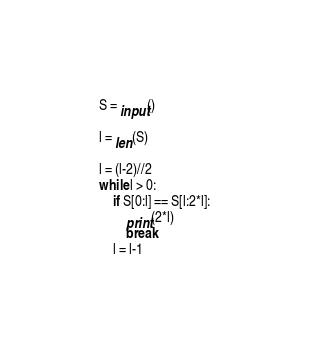Convert code to text. <code><loc_0><loc_0><loc_500><loc_500><_Python_>S = input()

l = len(S)

l = (l-2)//2
while l > 0:
    if S[0:l] == S[l:2*l]:
        print(2*l)
        break
    l = l-1
</code> 